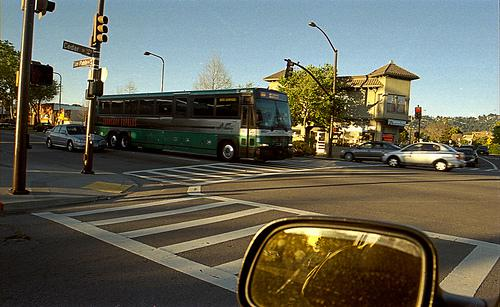Question: why is the photo illuminated?
Choices:
A. Flash.
B. Lighting.
C. Sunlight.
D. Glare.
Answer with the letter. Answer: C Question: when was this photo taken?
Choices:
A. After midnight.
B. Early in the morning.
C. During the day.
D. Right before dusk.
Answer with the letter. Answer: C Question: who is the subject of the photo?
Choices:
A. The house.
B. The fence.
C. The street.
D. The tree.
Answer with the letter. Answer: C Question: where was this photo taken?
Choices:
A. On country lane.
B. On the highway.
C. On city street.
D. On the airport runway.
Answer with the letter. Answer: C 